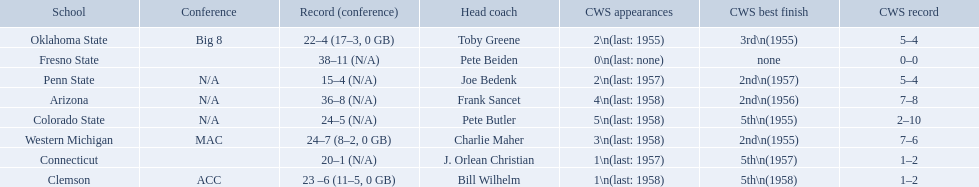What was the least amount of wins recorded by the losingest team? 15–4 (N/A). Which team held this record? Penn State. 